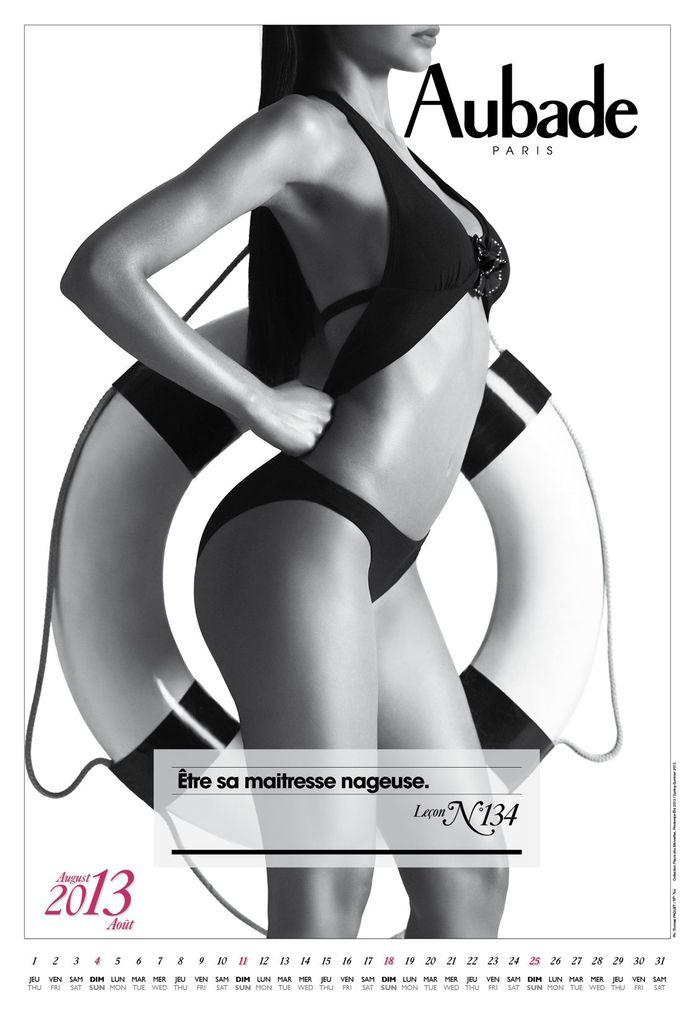What is the woman in the image doing? The woman is standing in the image and holding a tube. What else can be seen in the image besides the woman? There is text visible in the image, and the date is present in the bottom left side of the image. What is the color of the background in the image? The background of the image is white. How many birds are sitting on the dock in the image? There is no dock or birds present in the image. 